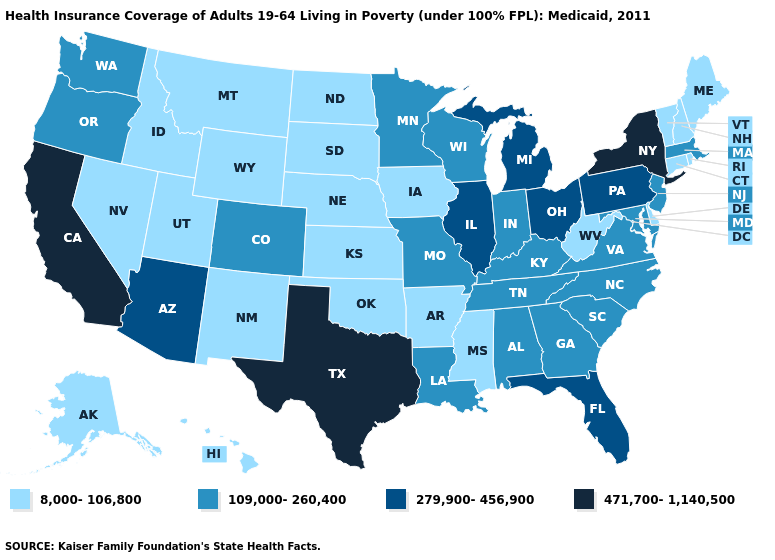Name the states that have a value in the range 279,900-456,900?
Be succinct. Arizona, Florida, Illinois, Michigan, Ohio, Pennsylvania. Name the states that have a value in the range 279,900-456,900?
Write a very short answer. Arizona, Florida, Illinois, Michigan, Ohio, Pennsylvania. Name the states that have a value in the range 8,000-106,800?
Short answer required. Alaska, Arkansas, Connecticut, Delaware, Hawaii, Idaho, Iowa, Kansas, Maine, Mississippi, Montana, Nebraska, Nevada, New Hampshire, New Mexico, North Dakota, Oklahoma, Rhode Island, South Dakota, Utah, Vermont, West Virginia, Wyoming. Does Wisconsin have a lower value than Maryland?
Write a very short answer. No. Does New Jersey have the lowest value in the USA?
Concise answer only. No. Name the states that have a value in the range 8,000-106,800?
Give a very brief answer. Alaska, Arkansas, Connecticut, Delaware, Hawaii, Idaho, Iowa, Kansas, Maine, Mississippi, Montana, Nebraska, Nevada, New Hampshire, New Mexico, North Dakota, Oklahoma, Rhode Island, South Dakota, Utah, Vermont, West Virginia, Wyoming. Among the states that border Nevada , which have the highest value?
Keep it brief. California. Which states have the lowest value in the USA?
Write a very short answer. Alaska, Arkansas, Connecticut, Delaware, Hawaii, Idaho, Iowa, Kansas, Maine, Mississippi, Montana, Nebraska, Nevada, New Hampshire, New Mexico, North Dakota, Oklahoma, Rhode Island, South Dakota, Utah, Vermont, West Virginia, Wyoming. What is the highest value in states that border New York?
Answer briefly. 279,900-456,900. Among the states that border Missouri , does Kansas have the highest value?
Keep it brief. No. What is the highest value in the USA?
Give a very brief answer. 471,700-1,140,500. Among the states that border Washington , does Oregon have the lowest value?
Be succinct. No. Does the map have missing data?
Short answer required. No. Among the states that border Montana , which have the highest value?
Be succinct. Idaho, North Dakota, South Dakota, Wyoming. What is the value of North Carolina?
Concise answer only. 109,000-260,400. 